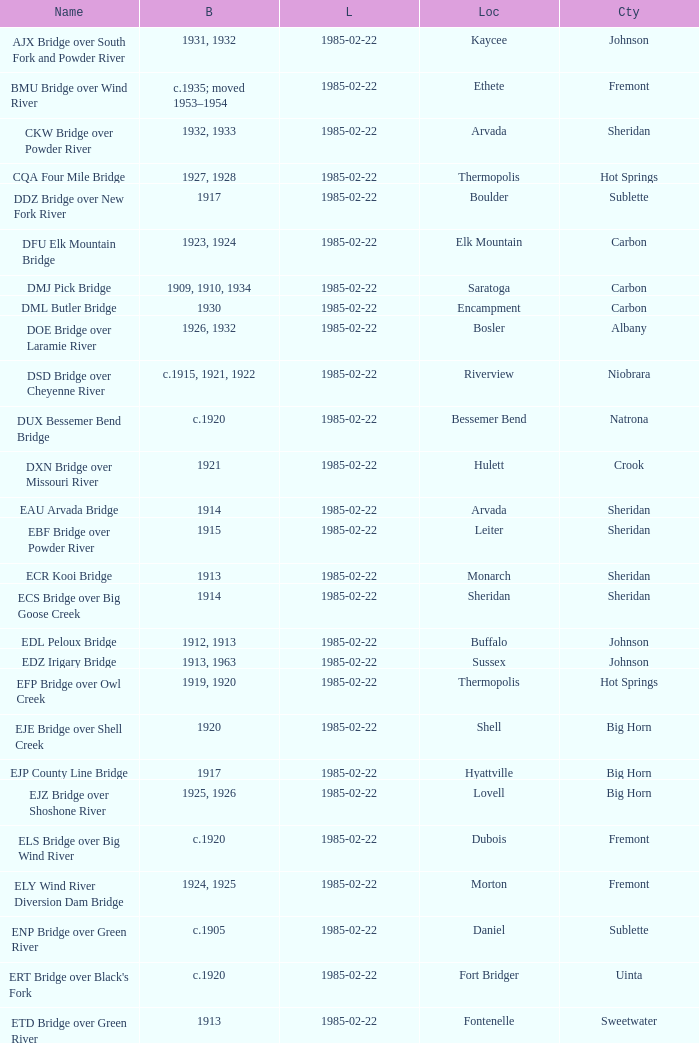In what year was the bridge in Lovell built? 1925, 1926. 